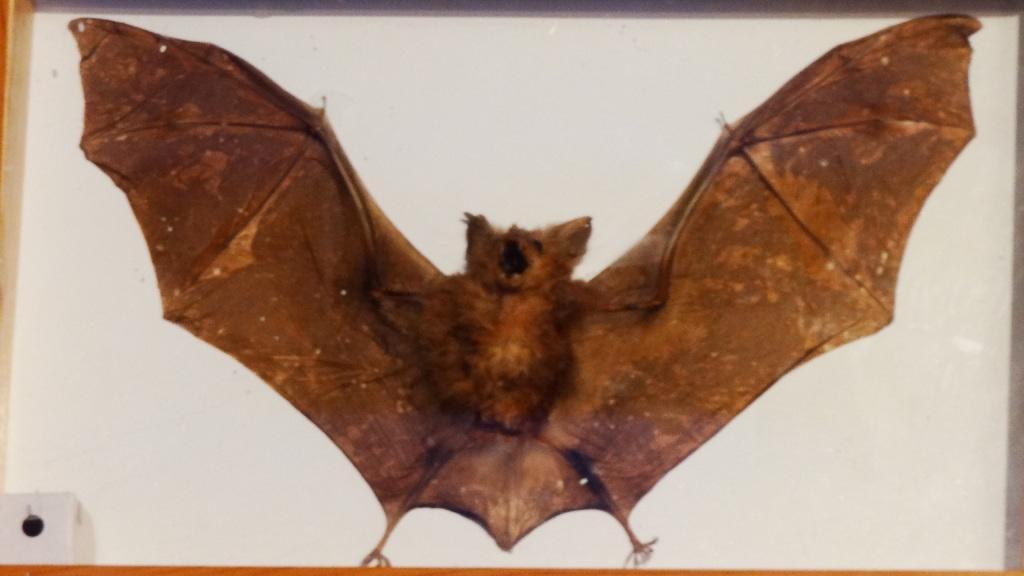Please provide a concise description of this image. In the center of the image we can see a bat. 